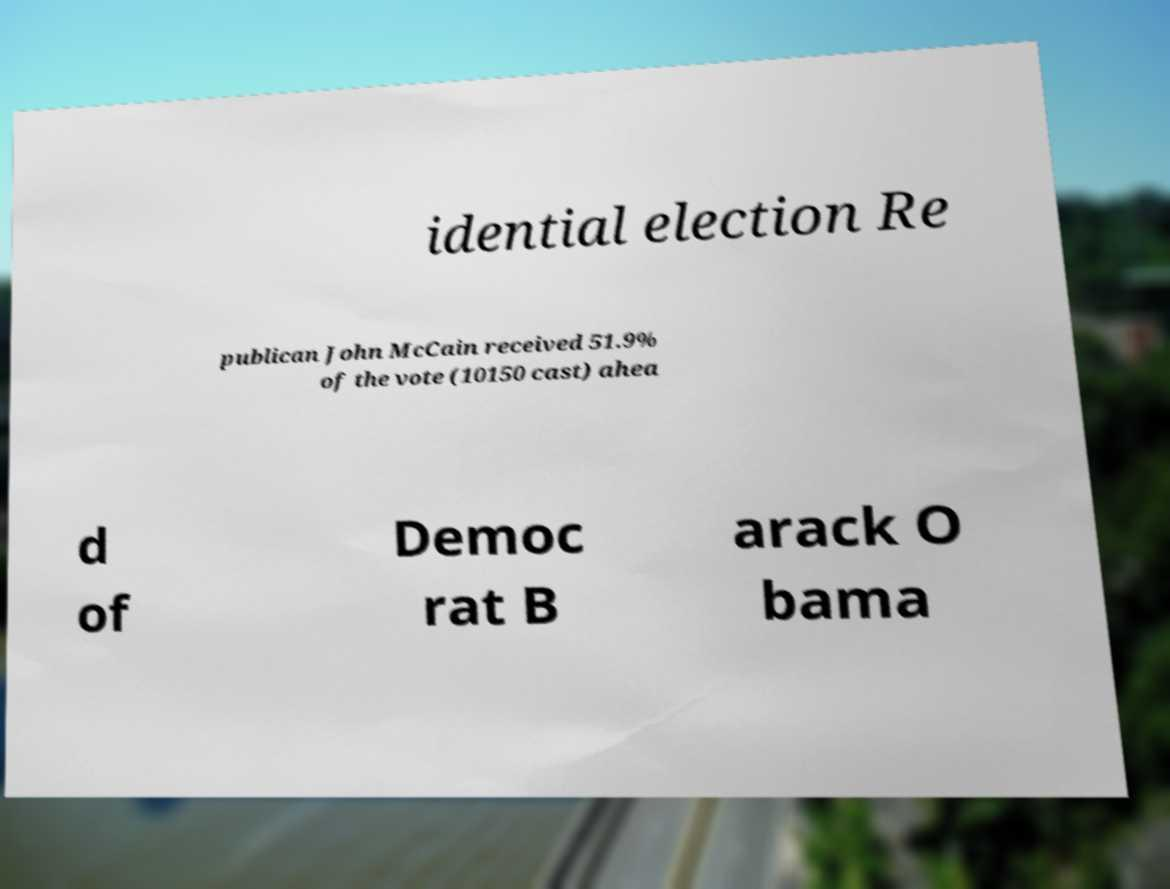There's text embedded in this image that I need extracted. Can you transcribe it verbatim? idential election Re publican John McCain received 51.9% of the vote (10150 cast) ahea d of Democ rat B arack O bama 